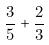<formula> <loc_0><loc_0><loc_500><loc_500>\frac { 3 } { 5 } + \frac { 2 } { 3 }</formula> 